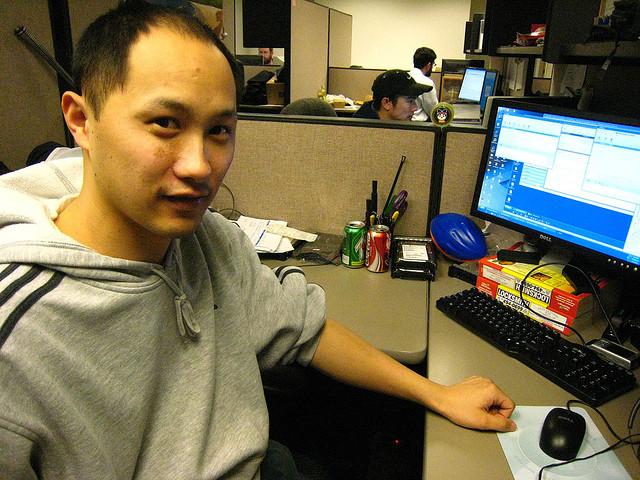What color is the man's shirt?
Short answer required. Gray. What material is the football on his desk made from?
Concise answer only. Foam. How many windows are open on the computer screen?
Write a very short answer. 4. Does he drink soda?
Give a very brief answer. Yes. 